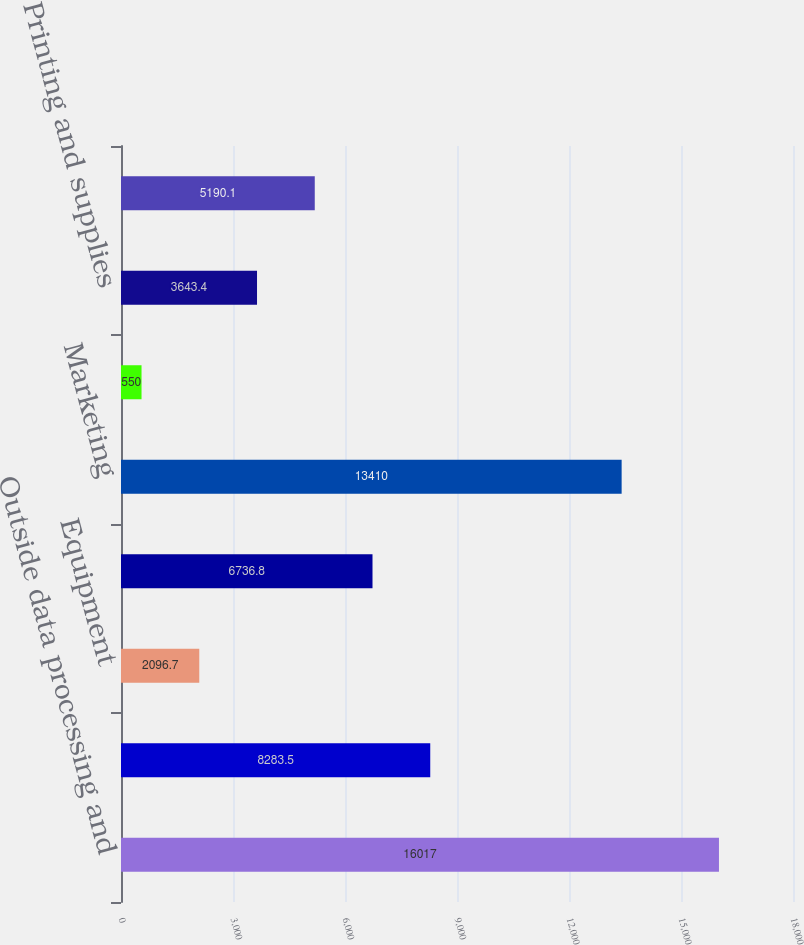Convert chart to OTSL. <chart><loc_0><loc_0><loc_500><loc_500><bar_chart><fcel>Outside data processing and<fcel>Net occupancy<fcel>Equipment<fcel>Professional services<fcel>Marketing<fcel>Telecommunications<fcel>Printing and supplies<fcel>Other expense<nl><fcel>16017<fcel>8283.5<fcel>2096.7<fcel>6736.8<fcel>13410<fcel>550<fcel>3643.4<fcel>5190.1<nl></chart> 